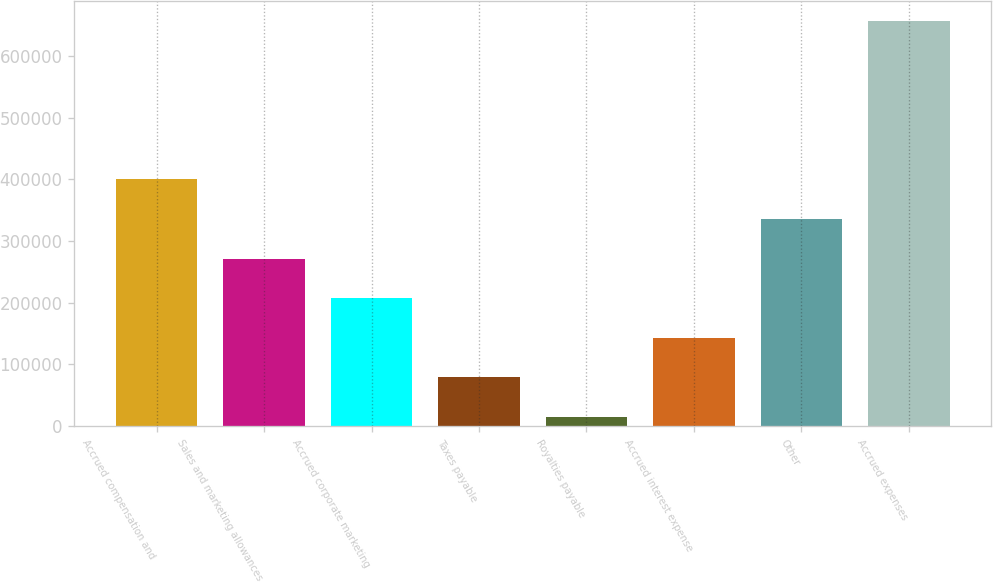Convert chart to OTSL. <chart><loc_0><loc_0><loc_500><loc_500><bar_chart><fcel>Accrued compensation and<fcel>Sales and marketing allowances<fcel>Accrued corporate marketing<fcel>Taxes payable<fcel>Royalties payable<fcel>Accrued interest expense<fcel>Other<fcel>Accrued expenses<nl><fcel>400075<fcel>271642<fcel>207426<fcel>78994.1<fcel>14778<fcel>143210<fcel>335858<fcel>656939<nl></chart> 